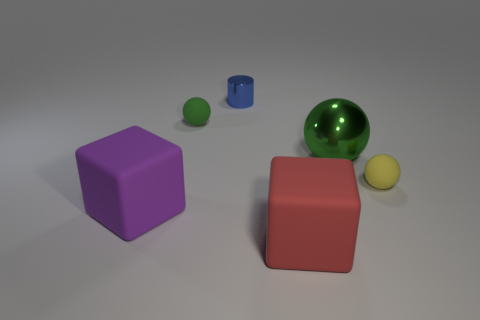Add 4 large green things. How many objects exist? 10 Subtract all brown metal spheres. Subtract all red blocks. How many objects are left? 5 Add 2 small yellow rubber objects. How many small yellow rubber objects are left? 3 Add 2 tiny blue things. How many tiny blue things exist? 3 Subtract 0 blue blocks. How many objects are left? 6 Subtract all blocks. How many objects are left? 4 